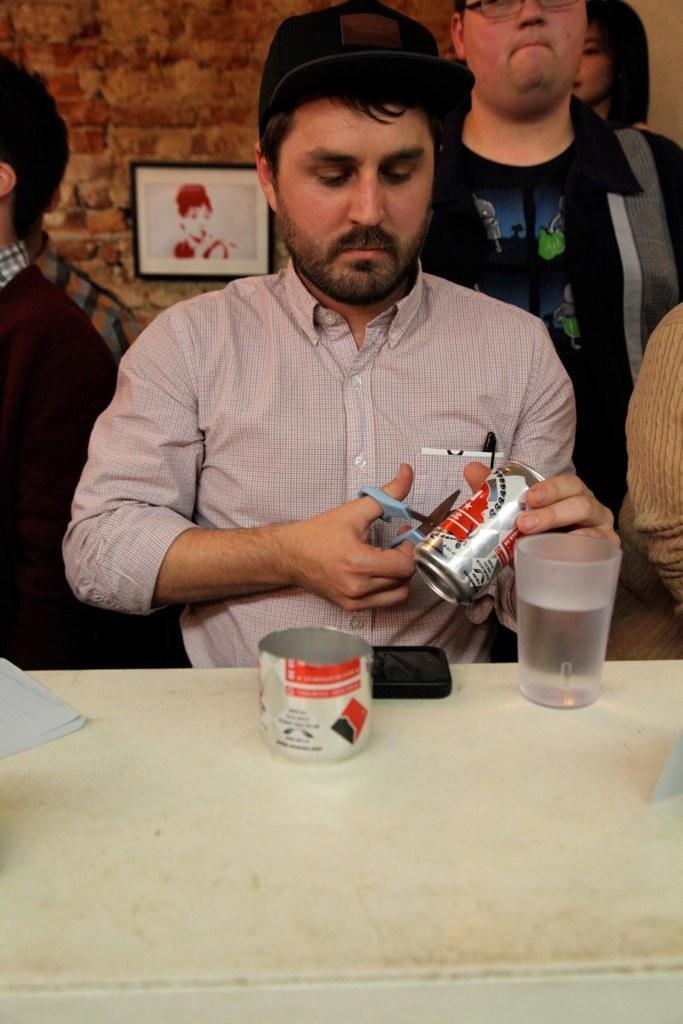Could you give a brief overview of what you see in this image? In this picture there is a man and cutting a beverage can, there is also a table in front him which has a water glass. There are some people, a wall and a photo frame in the background. 